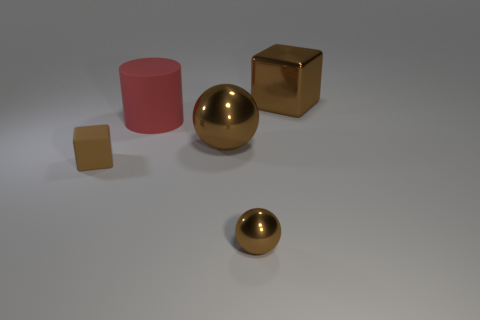Add 3 tiny red metal objects. How many objects exist? 8 Subtract all cubes. How many objects are left? 3 Subtract all red balls. How many purple blocks are left? 0 Subtract all small yellow objects. Subtract all small brown metal objects. How many objects are left? 4 Add 2 rubber cylinders. How many rubber cylinders are left? 3 Add 4 brown shiny balls. How many brown shiny balls exist? 6 Subtract 0 blue spheres. How many objects are left? 5 Subtract 1 balls. How many balls are left? 1 Subtract all cyan cylinders. Subtract all blue blocks. How many cylinders are left? 1 